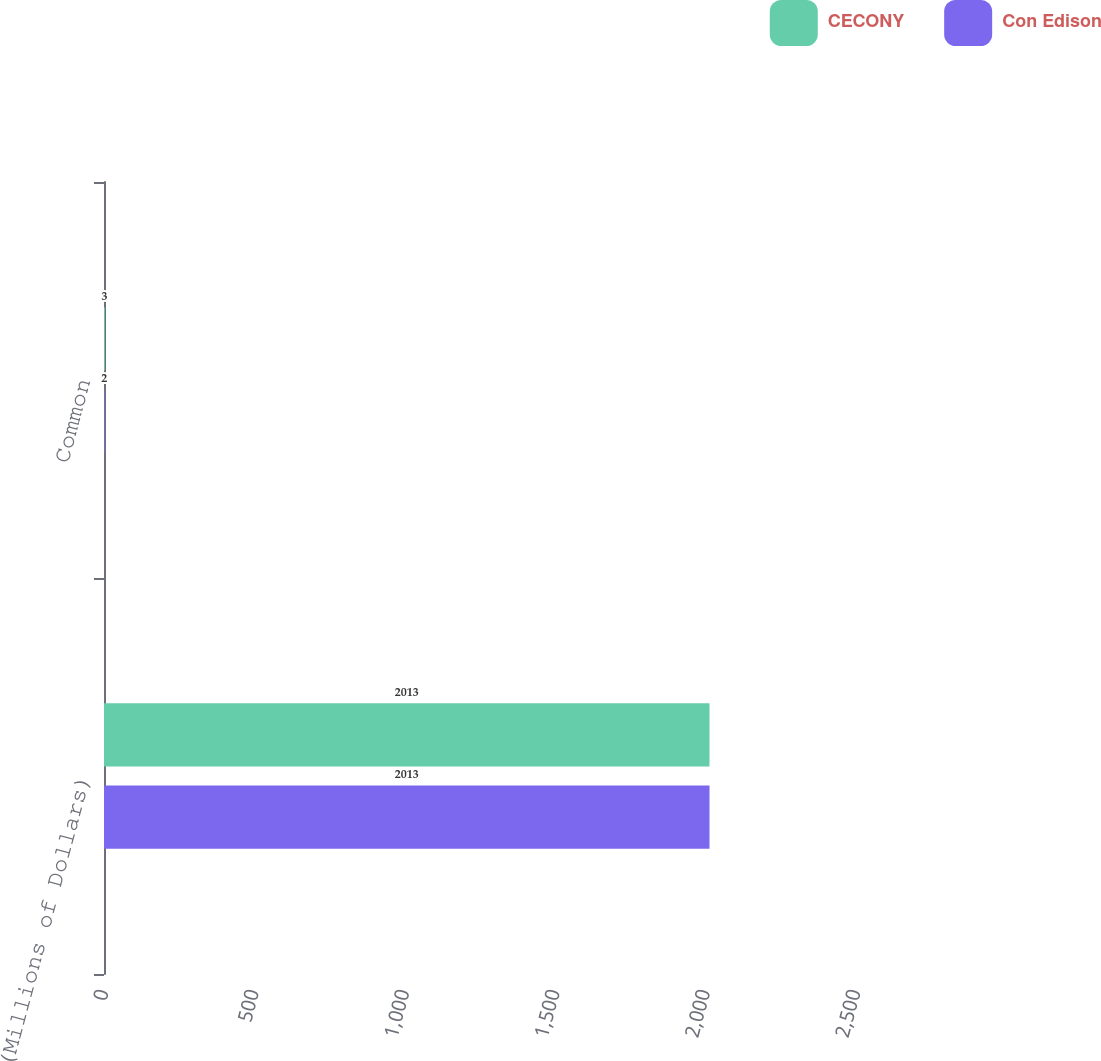Convert chart to OTSL. <chart><loc_0><loc_0><loc_500><loc_500><stacked_bar_chart><ecel><fcel>(Millions of Dollars)<fcel>Common<nl><fcel>CECONY<fcel>2013<fcel>3<nl><fcel>Con Edison<fcel>2013<fcel>2<nl></chart> 